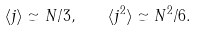Convert formula to latex. <formula><loc_0><loc_0><loc_500><loc_500>\langle j \rangle \simeq N / 3 , \quad \langle j ^ { 2 } \rangle \simeq N ^ { 2 } / 6 .</formula> 